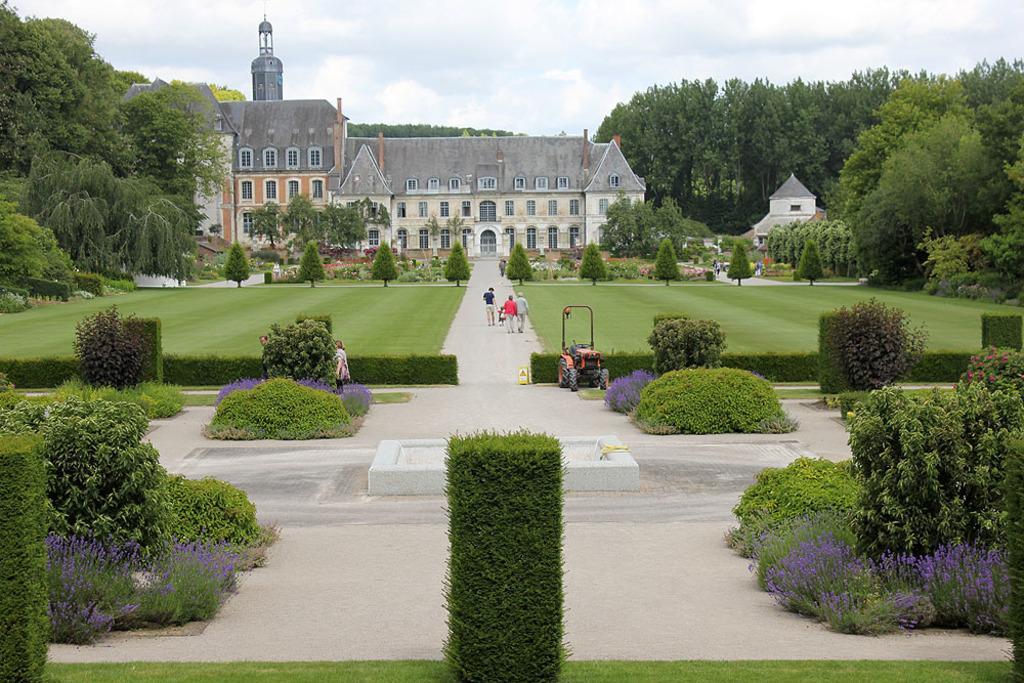Describe this image in one or two sentences. This place is looking like a garden. Here I can see many plants on the ground. In the background there is a building. In the front I can see a road on which few people are walking. On both sides of the road I can see the grass. In the background there are many trees. On the top of the image I can see the sky. 